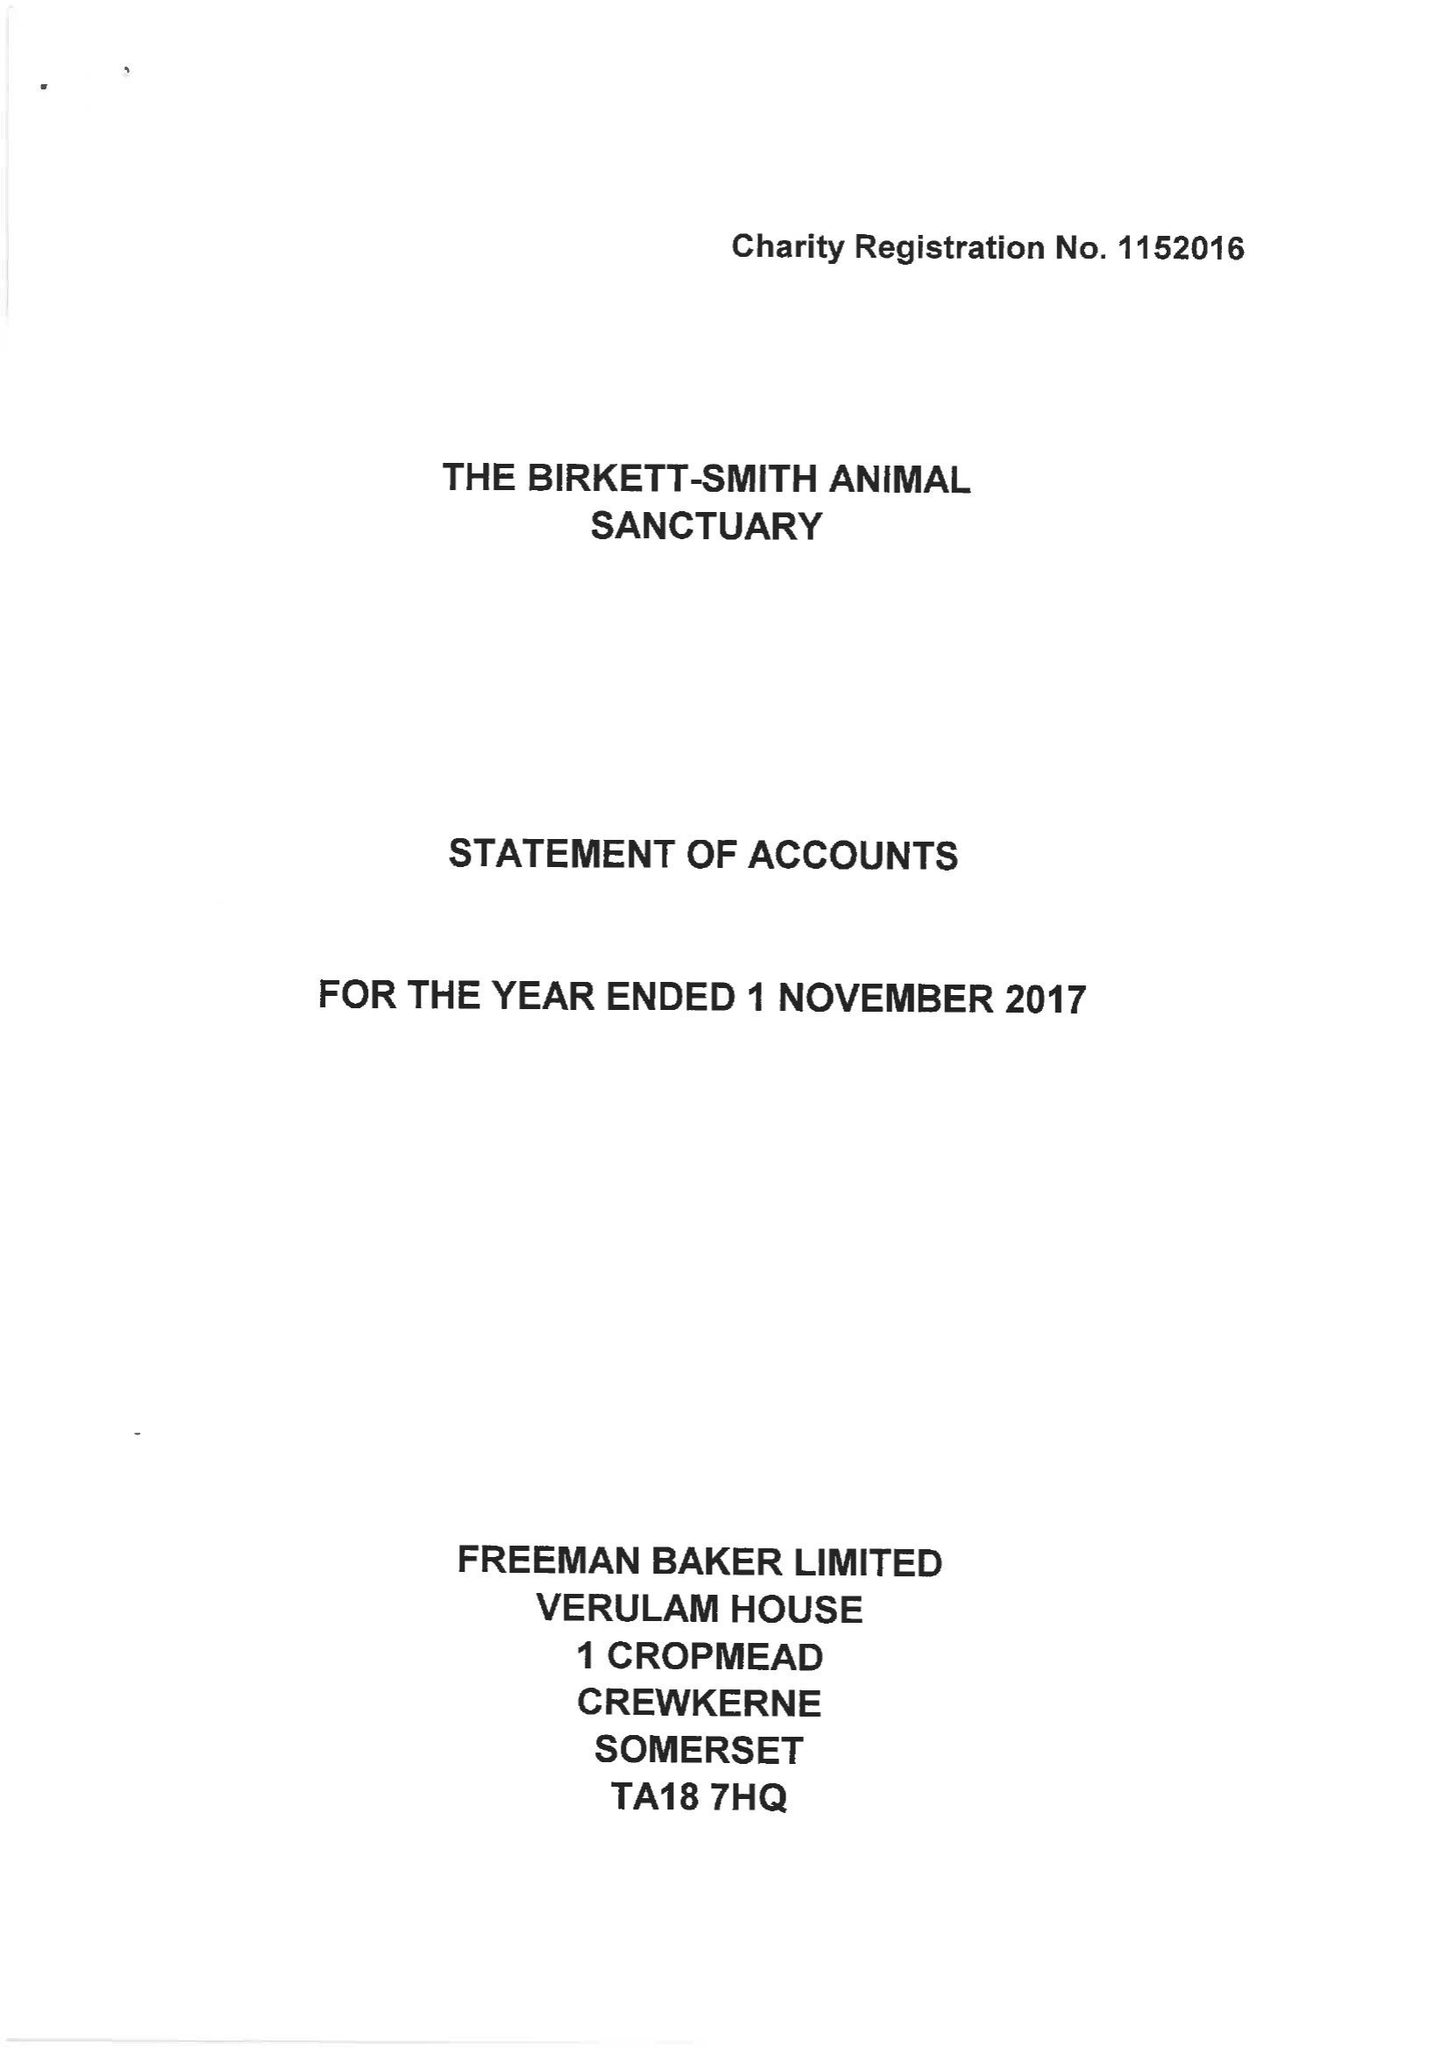What is the value for the address__postcode?
Answer the question using a single word or phrase. DT6 5NX 